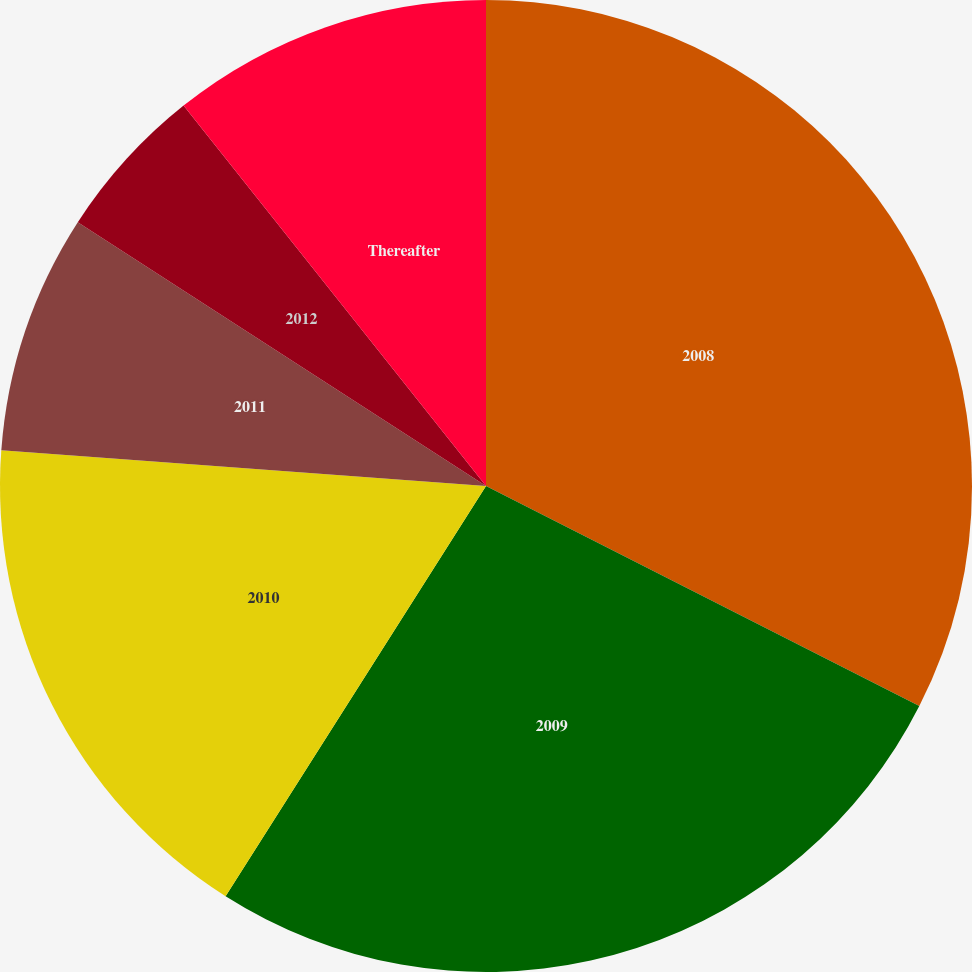Convert chart to OTSL. <chart><loc_0><loc_0><loc_500><loc_500><pie_chart><fcel>2008<fcel>2009<fcel>2010<fcel>2011<fcel>2012<fcel>Thereafter<nl><fcel>32.48%<fcel>26.52%<fcel>17.17%<fcel>7.96%<fcel>5.18%<fcel>10.69%<nl></chart> 